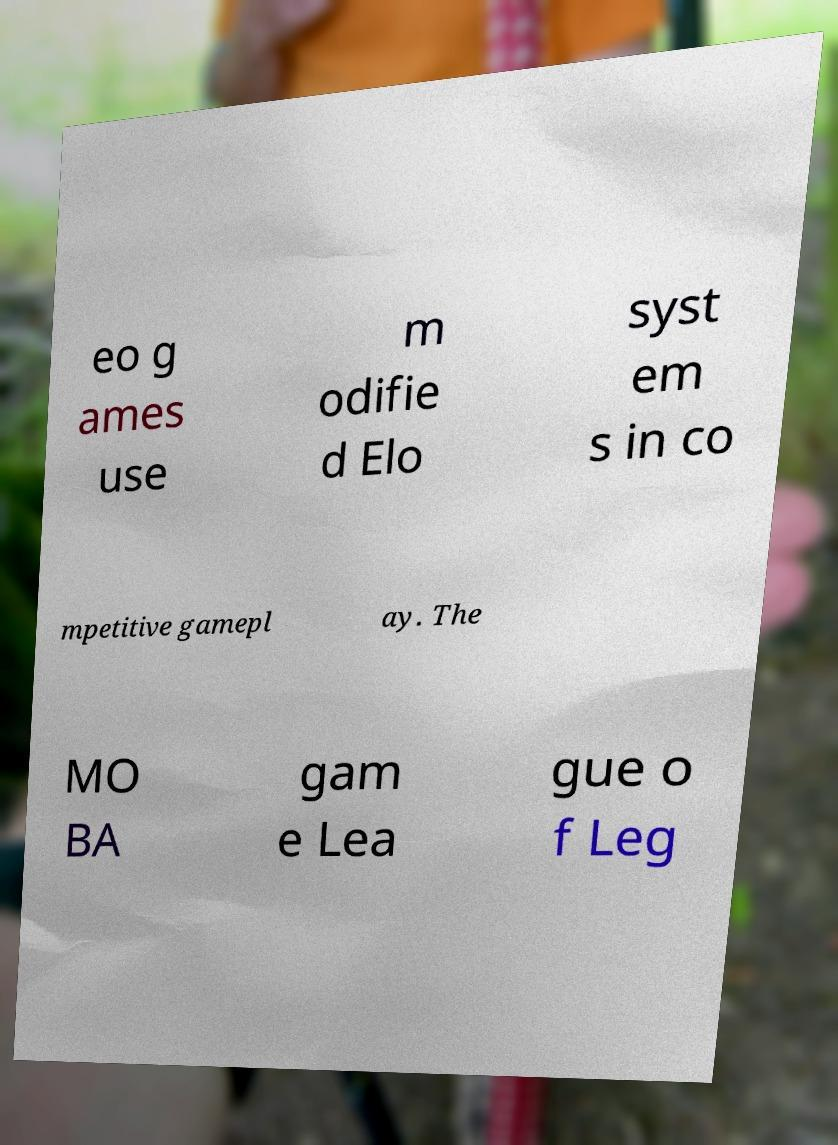For documentation purposes, I need the text within this image transcribed. Could you provide that? eo g ames use m odifie d Elo syst em s in co mpetitive gamepl ay. The MO BA gam e Lea gue o f Leg 